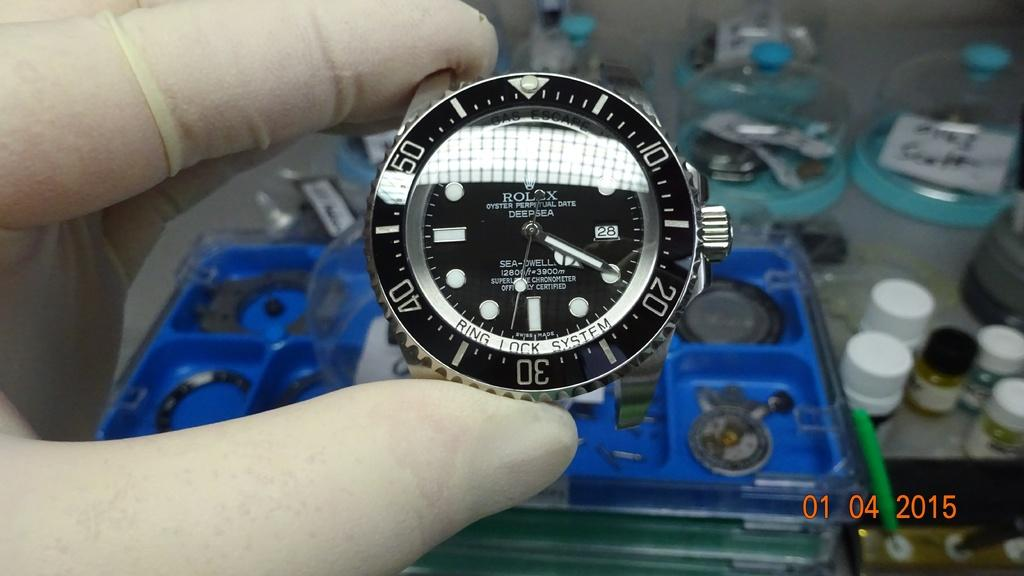What object is being held by a human hand in the image? A Rolex watch is being held by a human hand in the image. What brand is the watch being held? The watch is a Rolex. What color is the Rolex watch? The Rolex watch is black in color. Where is the pear located in the image? There is no pear present in the image. What type of calendar is visible in the image? There is no calendar present in the image. 